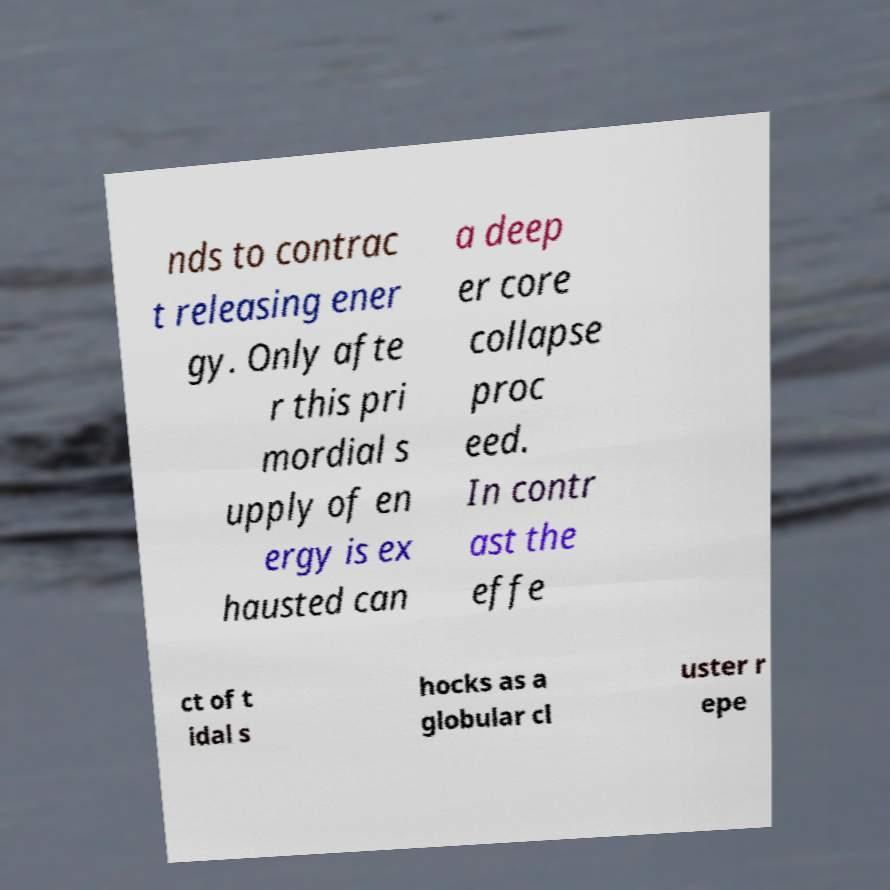Please identify and transcribe the text found in this image. nds to contrac t releasing ener gy. Only afte r this pri mordial s upply of en ergy is ex hausted can a deep er core collapse proc eed. In contr ast the effe ct of t idal s hocks as a globular cl uster r epe 